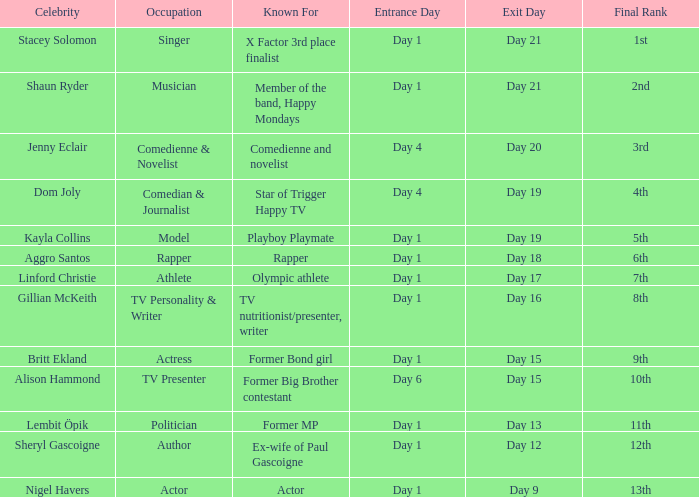Which well-known personality is renowned for their acting profession? Nigel Havers. 